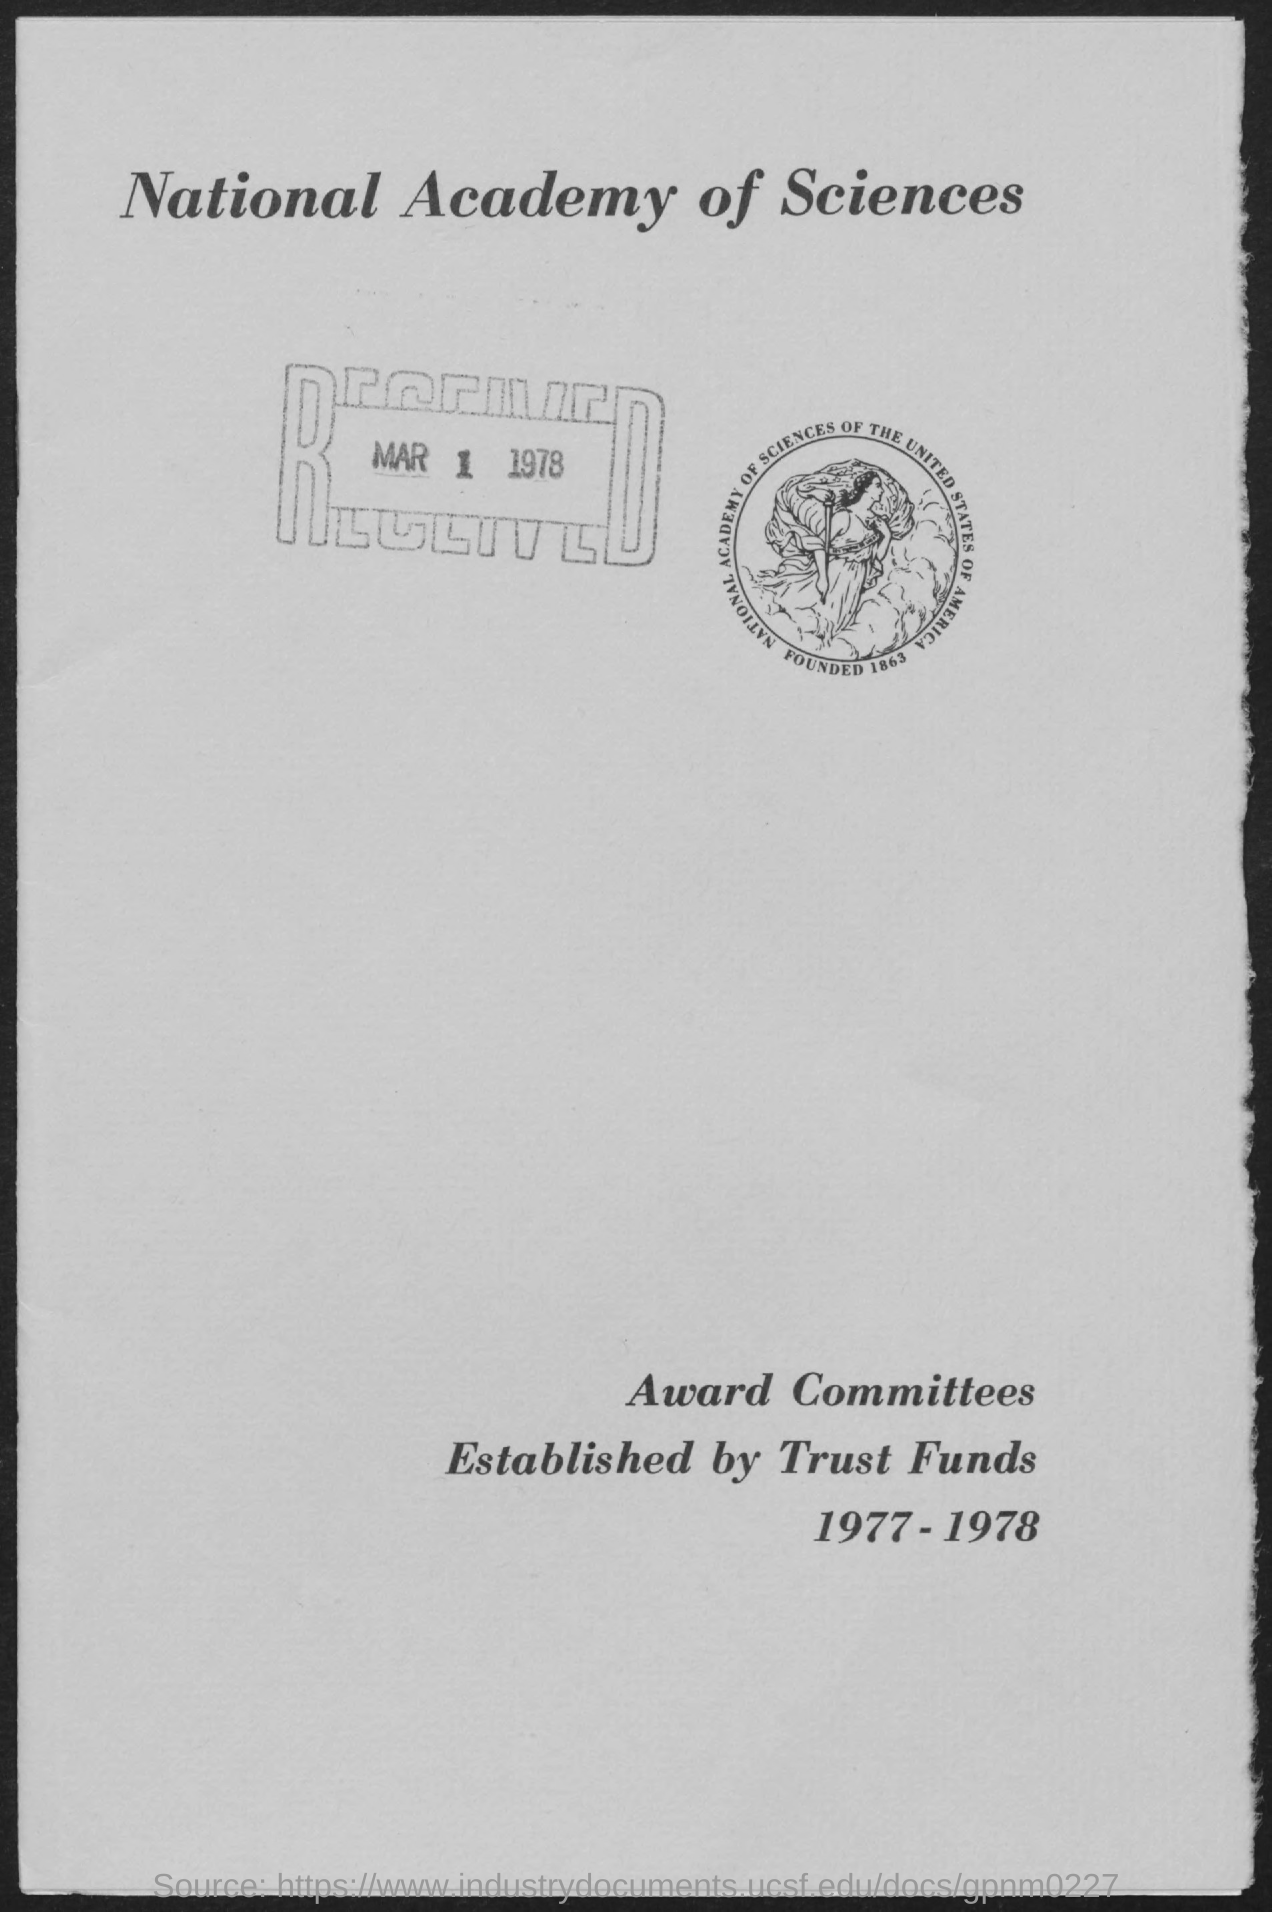Mention a couple of crucial points in this snapshot. The establishment of award committees and trust funds was done by [person/organization]. The document in question is titled the National Academy of Sciences. It was received on March 1, 1978. 